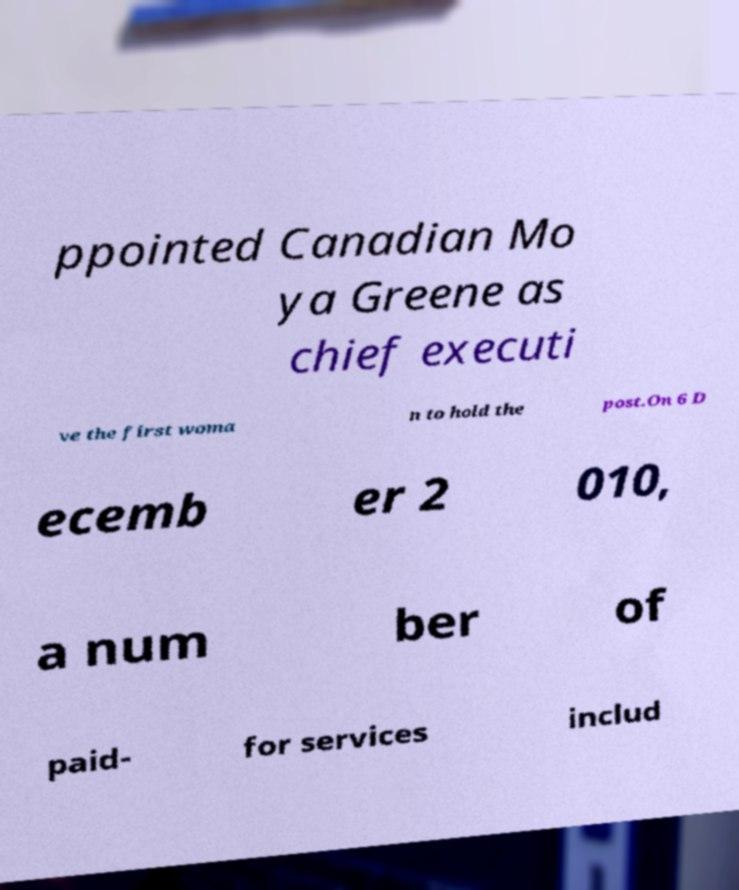Please read and relay the text visible in this image. What does it say? ppointed Canadian Mo ya Greene as chief executi ve the first woma n to hold the post.On 6 D ecemb er 2 010, a num ber of paid- for services includ 